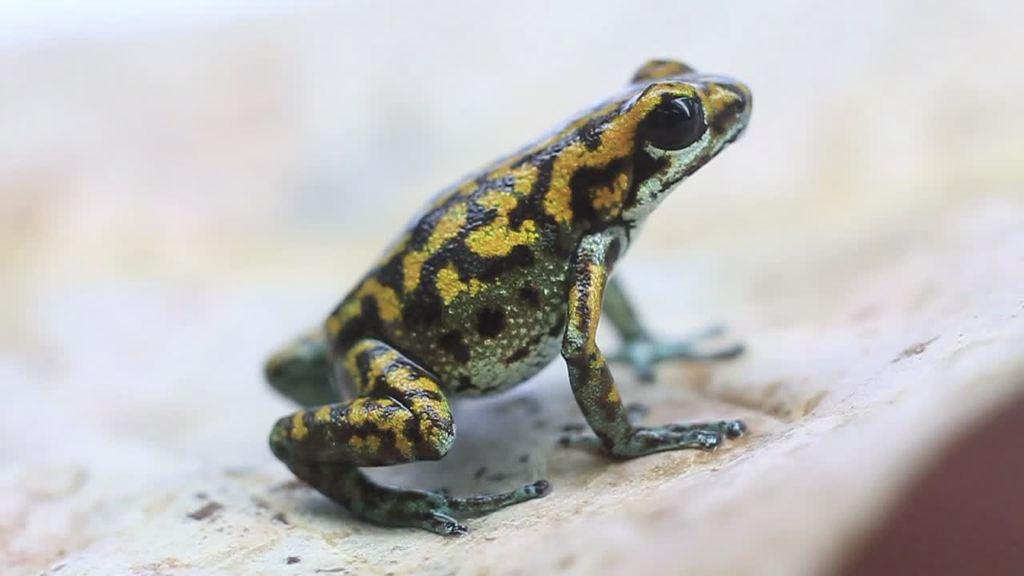What animal is present in the image? There is a frog in the image. Where is the frog located? The frog is on the surface in the image. Can you describe the background of the image? The background of the image is blurry. Is the frog wearing a mask in the image? There is no mask present in the image, and the frog is not wearing any accessories. 